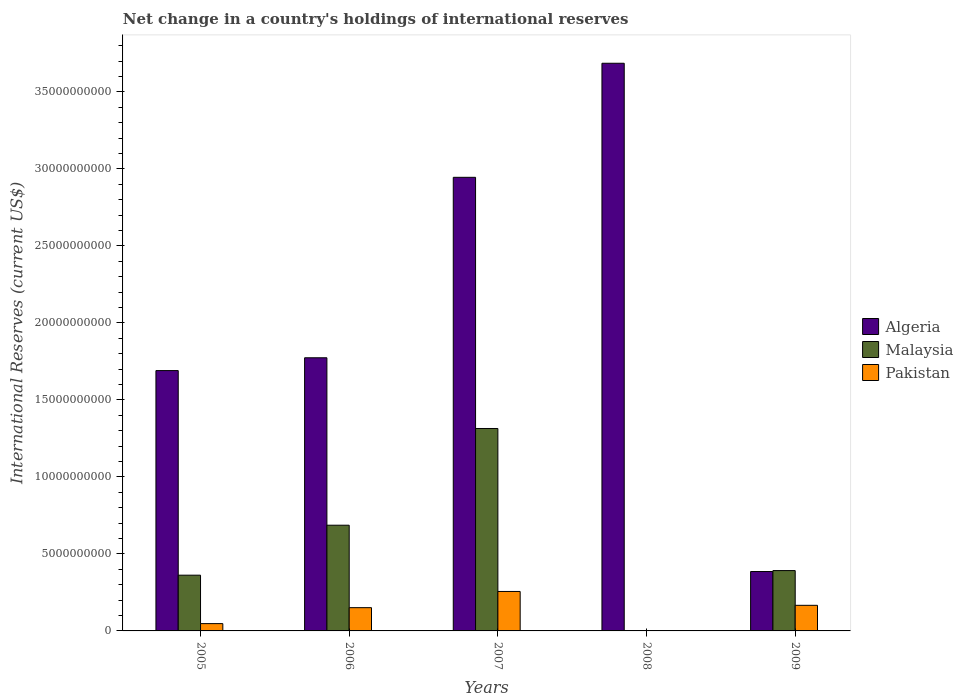How many different coloured bars are there?
Offer a very short reply. 3. What is the label of the 5th group of bars from the left?
Ensure brevity in your answer.  2009. In how many cases, is the number of bars for a given year not equal to the number of legend labels?
Provide a succinct answer. 1. What is the international reserves in Malaysia in 2006?
Give a very brief answer. 6.86e+09. Across all years, what is the maximum international reserves in Algeria?
Your answer should be very brief. 3.69e+1. Across all years, what is the minimum international reserves in Algeria?
Keep it short and to the point. 3.86e+09. In which year was the international reserves in Malaysia maximum?
Your response must be concise. 2007. What is the total international reserves in Algeria in the graph?
Your answer should be compact. 1.05e+11. What is the difference between the international reserves in Pakistan in 2006 and that in 2007?
Your answer should be very brief. -1.05e+09. What is the difference between the international reserves in Malaysia in 2007 and the international reserves in Pakistan in 2009?
Your answer should be very brief. 1.15e+1. What is the average international reserves in Malaysia per year?
Your response must be concise. 5.51e+09. In the year 2007, what is the difference between the international reserves in Algeria and international reserves in Malaysia?
Offer a very short reply. 1.63e+1. What is the ratio of the international reserves in Malaysia in 2005 to that in 2006?
Provide a succinct answer. 0.53. Is the international reserves in Algeria in 2005 less than that in 2009?
Your response must be concise. No. What is the difference between the highest and the second highest international reserves in Malaysia?
Your answer should be very brief. 6.28e+09. What is the difference between the highest and the lowest international reserves in Algeria?
Make the answer very short. 3.30e+1. Are all the bars in the graph horizontal?
Ensure brevity in your answer.  No. How many years are there in the graph?
Ensure brevity in your answer.  5. Does the graph contain grids?
Keep it short and to the point. No. Where does the legend appear in the graph?
Offer a terse response. Center right. What is the title of the graph?
Your answer should be compact. Net change in a country's holdings of international reserves. Does "Gabon" appear as one of the legend labels in the graph?
Offer a terse response. No. What is the label or title of the X-axis?
Ensure brevity in your answer.  Years. What is the label or title of the Y-axis?
Provide a short and direct response. International Reserves (current US$). What is the International Reserves (current US$) in Algeria in 2005?
Provide a succinct answer. 1.69e+1. What is the International Reserves (current US$) in Malaysia in 2005?
Ensure brevity in your answer.  3.62e+09. What is the International Reserves (current US$) of Pakistan in 2005?
Keep it short and to the point. 4.75e+08. What is the International Reserves (current US$) in Algeria in 2006?
Keep it short and to the point. 1.77e+1. What is the International Reserves (current US$) of Malaysia in 2006?
Give a very brief answer. 6.86e+09. What is the International Reserves (current US$) in Pakistan in 2006?
Make the answer very short. 1.51e+09. What is the International Reserves (current US$) in Algeria in 2007?
Keep it short and to the point. 2.95e+1. What is the International Reserves (current US$) in Malaysia in 2007?
Make the answer very short. 1.31e+1. What is the International Reserves (current US$) in Pakistan in 2007?
Give a very brief answer. 2.56e+09. What is the International Reserves (current US$) in Algeria in 2008?
Provide a short and direct response. 3.69e+1. What is the International Reserves (current US$) of Pakistan in 2008?
Provide a succinct answer. 0. What is the International Reserves (current US$) of Algeria in 2009?
Your response must be concise. 3.86e+09. What is the International Reserves (current US$) in Malaysia in 2009?
Ensure brevity in your answer.  3.92e+09. What is the International Reserves (current US$) in Pakistan in 2009?
Provide a succinct answer. 1.66e+09. Across all years, what is the maximum International Reserves (current US$) of Algeria?
Your answer should be very brief. 3.69e+1. Across all years, what is the maximum International Reserves (current US$) of Malaysia?
Your answer should be very brief. 1.31e+1. Across all years, what is the maximum International Reserves (current US$) in Pakistan?
Keep it short and to the point. 2.56e+09. Across all years, what is the minimum International Reserves (current US$) in Algeria?
Your response must be concise. 3.86e+09. What is the total International Reserves (current US$) of Algeria in the graph?
Provide a short and direct response. 1.05e+11. What is the total International Reserves (current US$) in Malaysia in the graph?
Your answer should be compact. 2.75e+1. What is the total International Reserves (current US$) of Pakistan in the graph?
Give a very brief answer. 6.21e+09. What is the difference between the International Reserves (current US$) of Algeria in 2005 and that in 2006?
Provide a short and direct response. -8.32e+08. What is the difference between the International Reserves (current US$) in Malaysia in 2005 and that in 2006?
Your answer should be compact. -3.24e+09. What is the difference between the International Reserves (current US$) of Pakistan in 2005 and that in 2006?
Your response must be concise. -1.04e+09. What is the difference between the International Reserves (current US$) of Algeria in 2005 and that in 2007?
Ensure brevity in your answer.  -1.25e+1. What is the difference between the International Reserves (current US$) in Malaysia in 2005 and that in 2007?
Offer a very short reply. -9.52e+09. What is the difference between the International Reserves (current US$) in Pakistan in 2005 and that in 2007?
Offer a terse response. -2.09e+09. What is the difference between the International Reserves (current US$) of Algeria in 2005 and that in 2008?
Keep it short and to the point. -2.00e+1. What is the difference between the International Reserves (current US$) of Algeria in 2005 and that in 2009?
Give a very brief answer. 1.30e+1. What is the difference between the International Reserves (current US$) in Malaysia in 2005 and that in 2009?
Ensure brevity in your answer.  -2.98e+08. What is the difference between the International Reserves (current US$) of Pakistan in 2005 and that in 2009?
Provide a succinct answer. -1.19e+09. What is the difference between the International Reserves (current US$) in Algeria in 2006 and that in 2007?
Offer a terse response. -1.17e+1. What is the difference between the International Reserves (current US$) in Malaysia in 2006 and that in 2007?
Give a very brief answer. -6.28e+09. What is the difference between the International Reserves (current US$) of Pakistan in 2006 and that in 2007?
Give a very brief answer. -1.05e+09. What is the difference between the International Reserves (current US$) of Algeria in 2006 and that in 2008?
Provide a short and direct response. -1.91e+1. What is the difference between the International Reserves (current US$) in Algeria in 2006 and that in 2009?
Make the answer very short. 1.39e+1. What is the difference between the International Reserves (current US$) in Malaysia in 2006 and that in 2009?
Give a very brief answer. 2.95e+09. What is the difference between the International Reserves (current US$) in Pakistan in 2006 and that in 2009?
Make the answer very short. -1.52e+08. What is the difference between the International Reserves (current US$) in Algeria in 2007 and that in 2008?
Your response must be concise. -7.41e+09. What is the difference between the International Reserves (current US$) in Algeria in 2007 and that in 2009?
Provide a short and direct response. 2.56e+1. What is the difference between the International Reserves (current US$) of Malaysia in 2007 and that in 2009?
Make the answer very short. 9.23e+09. What is the difference between the International Reserves (current US$) in Pakistan in 2007 and that in 2009?
Your answer should be very brief. 8.99e+08. What is the difference between the International Reserves (current US$) in Algeria in 2008 and that in 2009?
Provide a succinct answer. 3.30e+1. What is the difference between the International Reserves (current US$) in Algeria in 2005 and the International Reserves (current US$) in Malaysia in 2006?
Provide a succinct answer. 1.00e+1. What is the difference between the International Reserves (current US$) of Algeria in 2005 and the International Reserves (current US$) of Pakistan in 2006?
Your answer should be compact. 1.54e+1. What is the difference between the International Reserves (current US$) of Malaysia in 2005 and the International Reserves (current US$) of Pakistan in 2006?
Ensure brevity in your answer.  2.11e+09. What is the difference between the International Reserves (current US$) in Algeria in 2005 and the International Reserves (current US$) in Malaysia in 2007?
Provide a succinct answer. 3.76e+09. What is the difference between the International Reserves (current US$) in Algeria in 2005 and the International Reserves (current US$) in Pakistan in 2007?
Offer a very short reply. 1.43e+1. What is the difference between the International Reserves (current US$) of Malaysia in 2005 and the International Reserves (current US$) of Pakistan in 2007?
Keep it short and to the point. 1.06e+09. What is the difference between the International Reserves (current US$) of Algeria in 2005 and the International Reserves (current US$) of Malaysia in 2009?
Keep it short and to the point. 1.30e+1. What is the difference between the International Reserves (current US$) of Algeria in 2005 and the International Reserves (current US$) of Pakistan in 2009?
Give a very brief answer. 1.52e+1. What is the difference between the International Reserves (current US$) of Malaysia in 2005 and the International Reserves (current US$) of Pakistan in 2009?
Your answer should be compact. 1.96e+09. What is the difference between the International Reserves (current US$) of Algeria in 2006 and the International Reserves (current US$) of Malaysia in 2007?
Your answer should be very brief. 4.59e+09. What is the difference between the International Reserves (current US$) in Algeria in 2006 and the International Reserves (current US$) in Pakistan in 2007?
Keep it short and to the point. 1.52e+1. What is the difference between the International Reserves (current US$) in Malaysia in 2006 and the International Reserves (current US$) in Pakistan in 2007?
Make the answer very short. 4.30e+09. What is the difference between the International Reserves (current US$) in Algeria in 2006 and the International Reserves (current US$) in Malaysia in 2009?
Give a very brief answer. 1.38e+1. What is the difference between the International Reserves (current US$) of Algeria in 2006 and the International Reserves (current US$) of Pakistan in 2009?
Your response must be concise. 1.61e+1. What is the difference between the International Reserves (current US$) in Malaysia in 2006 and the International Reserves (current US$) in Pakistan in 2009?
Provide a succinct answer. 5.20e+09. What is the difference between the International Reserves (current US$) in Algeria in 2007 and the International Reserves (current US$) in Malaysia in 2009?
Ensure brevity in your answer.  2.55e+1. What is the difference between the International Reserves (current US$) in Algeria in 2007 and the International Reserves (current US$) in Pakistan in 2009?
Ensure brevity in your answer.  2.78e+1. What is the difference between the International Reserves (current US$) in Malaysia in 2007 and the International Reserves (current US$) in Pakistan in 2009?
Keep it short and to the point. 1.15e+1. What is the difference between the International Reserves (current US$) of Algeria in 2008 and the International Reserves (current US$) of Malaysia in 2009?
Your answer should be very brief. 3.29e+1. What is the difference between the International Reserves (current US$) of Algeria in 2008 and the International Reserves (current US$) of Pakistan in 2009?
Make the answer very short. 3.52e+1. What is the average International Reserves (current US$) of Algeria per year?
Your response must be concise. 2.10e+1. What is the average International Reserves (current US$) of Malaysia per year?
Offer a very short reply. 5.51e+09. What is the average International Reserves (current US$) of Pakistan per year?
Offer a very short reply. 1.24e+09. In the year 2005, what is the difference between the International Reserves (current US$) of Algeria and International Reserves (current US$) of Malaysia?
Ensure brevity in your answer.  1.33e+1. In the year 2005, what is the difference between the International Reserves (current US$) in Algeria and International Reserves (current US$) in Pakistan?
Ensure brevity in your answer.  1.64e+1. In the year 2005, what is the difference between the International Reserves (current US$) of Malaysia and International Reserves (current US$) of Pakistan?
Your answer should be very brief. 3.14e+09. In the year 2006, what is the difference between the International Reserves (current US$) of Algeria and International Reserves (current US$) of Malaysia?
Ensure brevity in your answer.  1.09e+1. In the year 2006, what is the difference between the International Reserves (current US$) in Algeria and International Reserves (current US$) in Pakistan?
Ensure brevity in your answer.  1.62e+1. In the year 2006, what is the difference between the International Reserves (current US$) of Malaysia and International Reserves (current US$) of Pakistan?
Your answer should be very brief. 5.35e+09. In the year 2007, what is the difference between the International Reserves (current US$) of Algeria and International Reserves (current US$) of Malaysia?
Your answer should be compact. 1.63e+1. In the year 2007, what is the difference between the International Reserves (current US$) of Algeria and International Reserves (current US$) of Pakistan?
Provide a succinct answer. 2.69e+1. In the year 2007, what is the difference between the International Reserves (current US$) of Malaysia and International Reserves (current US$) of Pakistan?
Offer a terse response. 1.06e+1. In the year 2009, what is the difference between the International Reserves (current US$) of Algeria and International Reserves (current US$) of Malaysia?
Make the answer very short. -6.13e+07. In the year 2009, what is the difference between the International Reserves (current US$) in Algeria and International Reserves (current US$) in Pakistan?
Provide a short and direct response. 2.19e+09. In the year 2009, what is the difference between the International Reserves (current US$) of Malaysia and International Reserves (current US$) of Pakistan?
Offer a terse response. 2.26e+09. What is the ratio of the International Reserves (current US$) of Algeria in 2005 to that in 2006?
Offer a terse response. 0.95. What is the ratio of the International Reserves (current US$) of Malaysia in 2005 to that in 2006?
Make the answer very short. 0.53. What is the ratio of the International Reserves (current US$) in Pakistan in 2005 to that in 2006?
Your answer should be compact. 0.31. What is the ratio of the International Reserves (current US$) in Algeria in 2005 to that in 2007?
Make the answer very short. 0.57. What is the ratio of the International Reserves (current US$) of Malaysia in 2005 to that in 2007?
Make the answer very short. 0.28. What is the ratio of the International Reserves (current US$) in Pakistan in 2005 to that in 2007?
Offer a very short reply. 0.19. What is the ratio of the International Reserves (current US$) of Algeria in 2005 to that in 2008?
Provide a succinct answer. 0.46. What is the ratio of the International Reserves (current US$) in Algeria in 2005 to that in 2009?
Your answer should be compact. 4.38. What is the ratio of the International Reserves (current US$) in Malaysia in 2005 to that in 2009?
Make the answer very short. 0.92. What is the ratio of the International Reserves (current US$) of Pakistan in 2005 to that in 2009?
Make the answer very short. 0.29. What is the ratio of the International Reserves (current US$) of Algeria in 2006 to that in 2007?
Keep it short and to the point. 0.6. What is the ratio of the International Reserves (current US$) in Malaysia in 2006 to that in 2007?
Your response must be concise. 0.52. What is the ratio of the International Reserves (current US$) in Pakistan in 2006 to that in 2007?
Give a very brief answer. 0.59. What is the ratio of the International Reserves (current US$) of Algeria in 2006 to that in 2008?
Ensure brevity in your answer.  0.48. What is the ratio of the International Reserves (current US$) of Algeria in 2006 to that in 2009?
Offer a terse response. 4.6. What is the ratio of the International Reserves (current US$) of Malaysia in 2006 to that in 2009?
Keep it short and to the point. 1.75. What is the ratio of the International Reserves (current US$) of Pakistan in 2006 to that in 2009?
Your response must be concise. 0.91. What is the ratio of the International Reserves (current US$) in Algeria in 2007 to that in 2008?
Make the answer very short. 0.8. What is the ratio of the International Reserves (current US$) of Algeria in 2007 to that in 2009?
Your response must be concise. 7.64. What is the ratio of the International Reserves (current US$) of Malaysia in 2007 to that in 2009?
Provide a succinct answer. 3.35. What is the ratio of the International Reserves (current US$) of Pakistan in 2007 to that in 2009?
Provide a short and direct response. 1.54. What is the ratio of the International Reserves (current US$) in Algeria in 2008 to that in 2009?
Provide a short and direct response. 9.56. What is the difference between the highest and the second highest International Reserves (current US$) of Algeria?
Your answer should be compact. 7.41e+09. What is the difference between the highest and the second highest International Reserves (current US$) of Malaysia?
Provide a short and direct response. 6.28e+09. What is the difference between the highest and the second highest International Reserves (current US$) of Pakistan?
Provide a succinct answer. 8.99e+08. What is the difference between the highest and the lowest International Reserves (current US$) of Algeria?
Offer a very short reply. 3.30e+1. What is the difference between the highest and the lowest International Reserves (current US$) of Malaysia?
Offer a very short reply. 1.31e+1. What is the difference between the highest and the lowest International Reserves (current US$) of Pakistan?
Ensure brevity in your answer.  2.56e+09. 